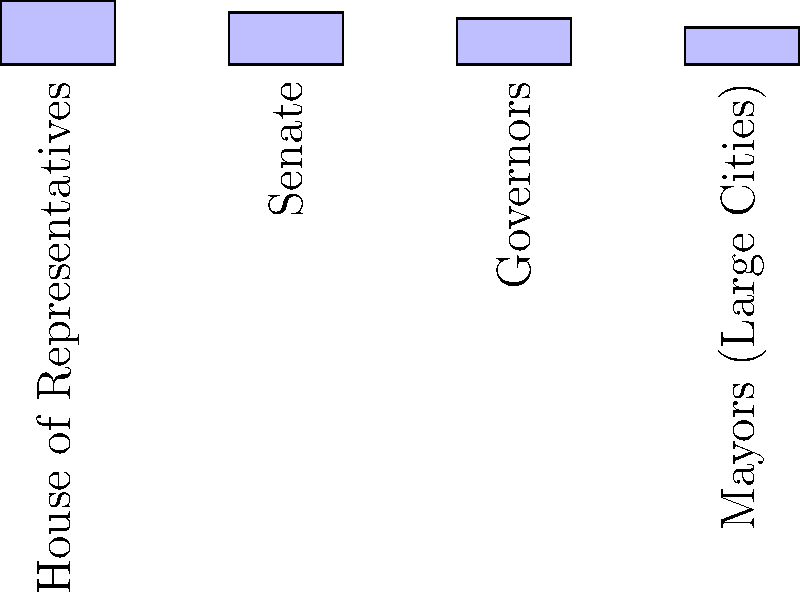As a social activist and feminist, you're analyzing the representation of women in various political offices. Based on the bar graph, which political office has the highest percentage of women, and what does this reveal about gender representation in American politics? To answer this question, we need to follow these steps:

1. Examine the bar graph, which shows the percentage of women in different political offices.

2. Identify the highest bar in the graph:
   - House of Representatives: 27.3%
   - Senate: 22.4%
   - Governors: 19.8%
   - Mayors (Large Cities): 15.9%

3. The highest bar corresponds to the House of Representatives at 27.3%.

4. Analyze what this reveals about gender representation:
   - Women are underrepresented in all shown political offices, as none reach 50%.
   - The House of Representatives has the highest representation, possibly due to more frequent elections and smaller districts.
   - There's a significant gap between women's representation in the population (approximately 50%) and their representation in political offices.
   - The data suggests a need for continued efforts to increase women's participation in politics at all levels.

5. As a feminist and social activist, this information can be used to advocate for more women in political roles and to address systemic barriers to women's political participation.
Answer: House of Representatives (27.3%); reveals significant underrepresentation of women across all levels of government. 